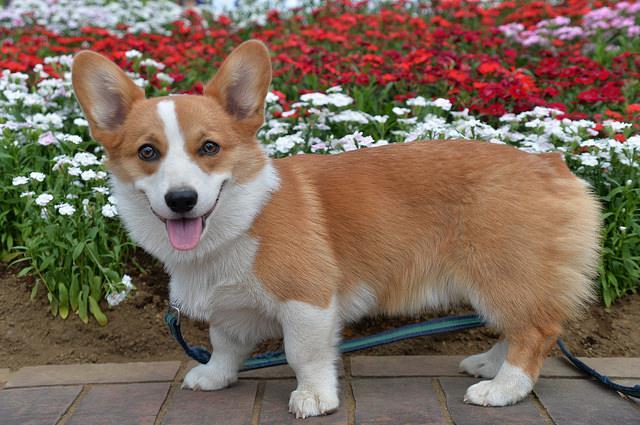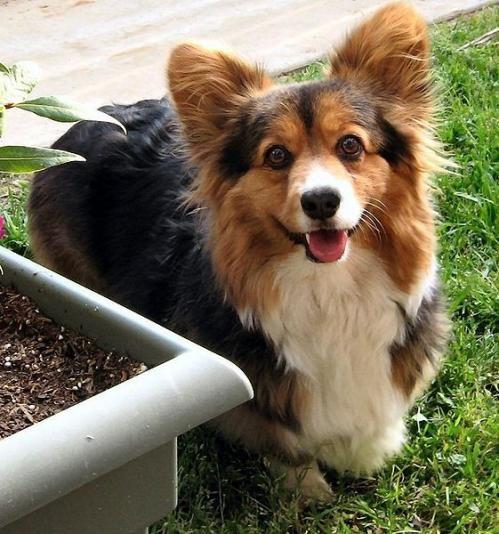The first image is the image on the left, the second image is the image on the right. Evaluate the accuracy of this statement regarding the images: "The dog in the left image is standing on all four legs with its body pointing left.". Is it true? Answer yes or no. Yes. The first image is the image on the left, the second image is the image on the right. Given the left and right images, does the statement "The image on the right shows a corgi puppy in movement and the left one shows a corgi puppy sitting down." hold true? Answer yes or no. No. 